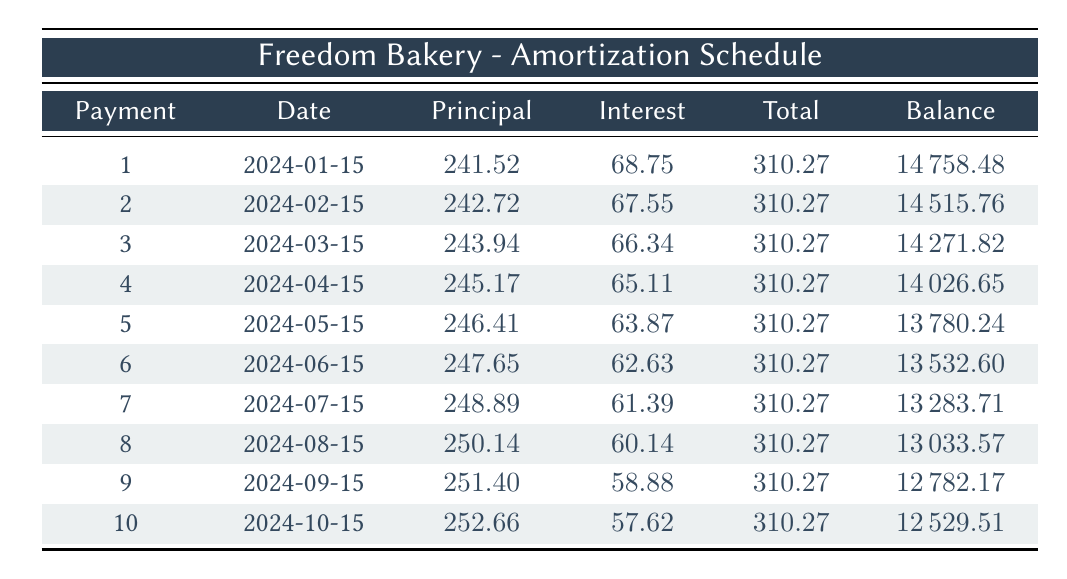What is the total payment made in the first month? The total payment for the first month is directly provided in the table under the "Total" column for payment number 1, which is 310.27.
Answer: 310.27 How much principal was paid off in the fifth payment? Looking at the "Principal" column for payment number 5, the amount paid towards the principal is 246.41.
Answer: 246.41 What is the remaining balance after three payments? The remaining balance after three payments is the value in the "Balance" column for payment number 3, which shows 14271.82.
Answer: 14271.82 Is the interest payment in the second month lower than in the first month? By comparing the "Interest" payments of the first and second months, we see that the first month has an interest payment of 68.75, while the second month has an interest payment of 67.55, indicating that the second month's interest payment is lower.
Answer: Yes What is the average principal payment across all ten payments? To find the average, sum all the principal payments: (241.52 + 242.72 + 243.94 + 245.17 + 246.41 + 247.65 + 248.89 + 250.14 + 251.40 + 252.66) = 2470.70. Since there are 10 payments, the average principal payment is 2470.70/10 = 247.07.
Answer: 247.07 How much total payment will Anna make over the entire loan term? Since each payment is constant at 310.27 and there are 10 payments, the total payment over the entire term can be calculated as 310.27 * 10 = 3102.70.
Answer: 3102.70 What is the total interest paid in the first three months? To compute the total interest for the first three months, sum the interest payments. The first month is 68.75, the second month is 67.55, and the third month is 66.34. Thus, total interest = 68.75 + 67.55 + 66.34 = 202.64.
Answer: 202.64 Did the principal payment increase each month? By examining each row for the "Principal" column, we can see that each subsequent principal payment is higher than the last: 241.52, 242.72, 243.94, etc. Thus, the principal payments do indeed increase each month.
Answer: Yes What is the difference between the first and last remaining balance amount? The first remaining balance after the first payment is 14758.48, and the last remaining balance after the tenth payment is 12529.51. The difference is calculated as 14758.48 - 12529.51 = 2228.97.
Answer: 2228.97 